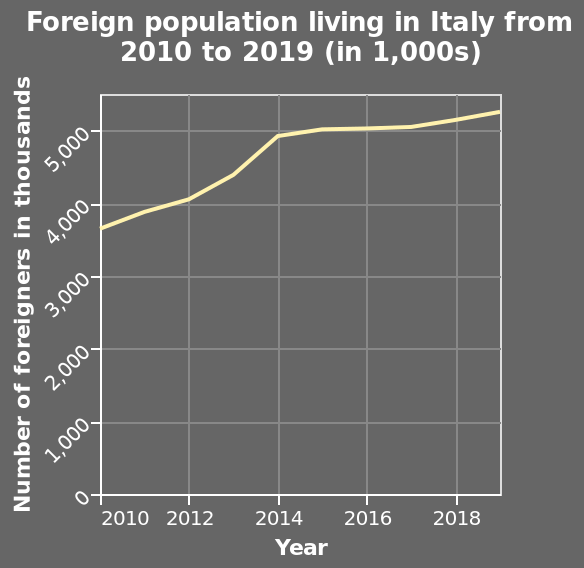<image>
What is the minimum value on the x-axis? The minimum value on the x-axis is 2010. please describe the details of the chart Here a line graph is titled Foreign population living in Italy from 2010 to 2019 (in 1,000s). On the x-axis, Year is drawn using a linear scale with a minimum of 2010 and a maximum of 2018. There is a linear scale from 0 to 5,000 along the y-axis, marked Number of foreigners in thousands. What is the range of the x-axis in the area chart?  The x-axis ranges from 2010 to 2018. What was the population of foreigners in Italy in 2019?  The population of foreigners in Italy in 2019 was 5250 thousand. What is the scale of the y-axis? The y-axis has a linear scale from 0 to 5,000. Was the population of foreigners in Italy in 2020 5250 thousand? No. The population of foreigners in Italy in 2019 was 5250 thousand. 